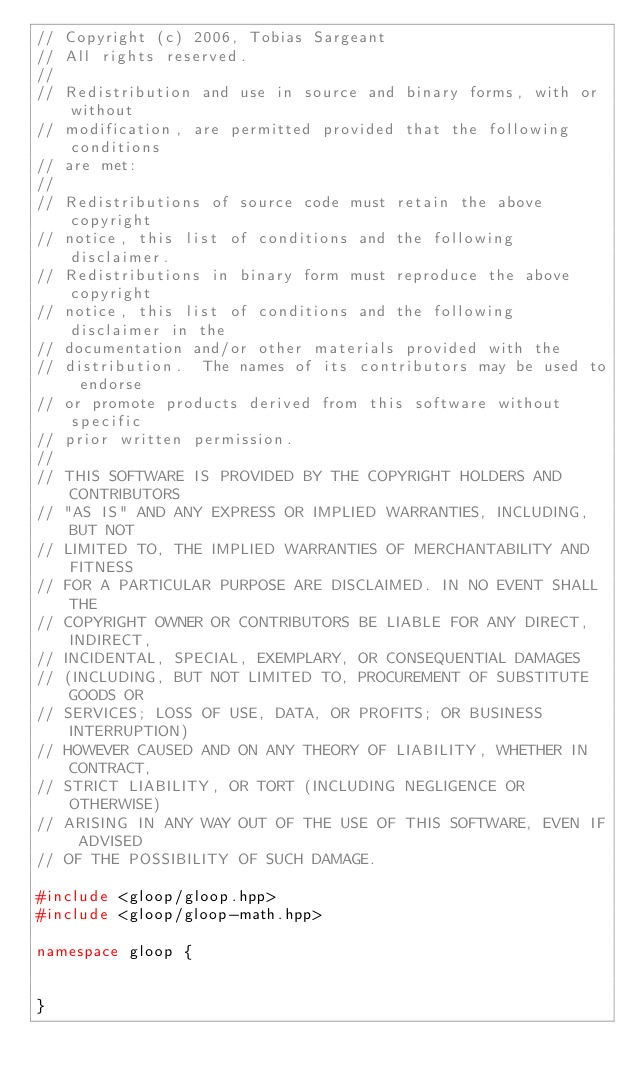Convert code to text. <code><loc_0><loc_0><loc_500><loc_500><_C++_>// Copyright (c) 2006, Tobias Sargeant
// All rights reserved.
//
// Redistribution and use in source and binary forms, with or without
// modification, are permitted provided that the following conditions
// are met:
//
// Redistributions of source code must retain the above copyright
// notice, this list of conditions and the following disclaimer.
// Redistributions in binary form must reproduce the above copyright
// notice, this list of conditions and the following disclaimer in the
// documentation and/or other materials provided with the
// distribution.  The names of its contributors may be used to endorse
// or promote products derived from this software without specific
// prior written permission.
//
// THIS SOFTWARE IS PROVIDED BY THE COPYRIGHT HOLDERS AND CONTRIBUTORS
// "AS IS" AND ANY EXPRESS OR IMPLIED WARRANTIES, INCLUDING, BUT NOT
// LIMITED TO, THE IMPLIED WARRANTIES OF MERCHANTABILITY AND FITNESS
// FOR A PARTICULAR PURPOSE ARE DISCLAIMED. IN NO EVENT SHALL THE
// COPYRIGHT OWNER OR CONTRIBUTORS BE LIABLE FOR ANY DIRECT, INDIRECT,
// INCIDENTAL, SPECIAL, EXEMPLARY, OR CONSEQUENTIAL DAMAGES
// (INCLUDING, BUT NOT LIMITED TO, PROCUREMENT OF SUBSTITUTE GOODS OR
// SERVICES; LOSS OF USE, DATA, OR PROFITS; OR BUSINESS INTERRUPTION)
// HOWEVER CAUSED AND ON ANY THEORY OF LIABILITY, WHETHER IN CONTRACT,
// STRICT LIABILITY, OR TORT (INCLUDING NEGLIGENCE OR OTHERWISE)
// ARISING IN ANY WAY OUT OF THE USE OF THIS SOFTWARE, EVEN IF ADVISED
// OF THE POSSIBILITY OF SUCH DAMAGE.

#include <gloop/gloop.hpp>
#include <gloop/gloop-math.hpp>

namespace gloop {


}
</code> 